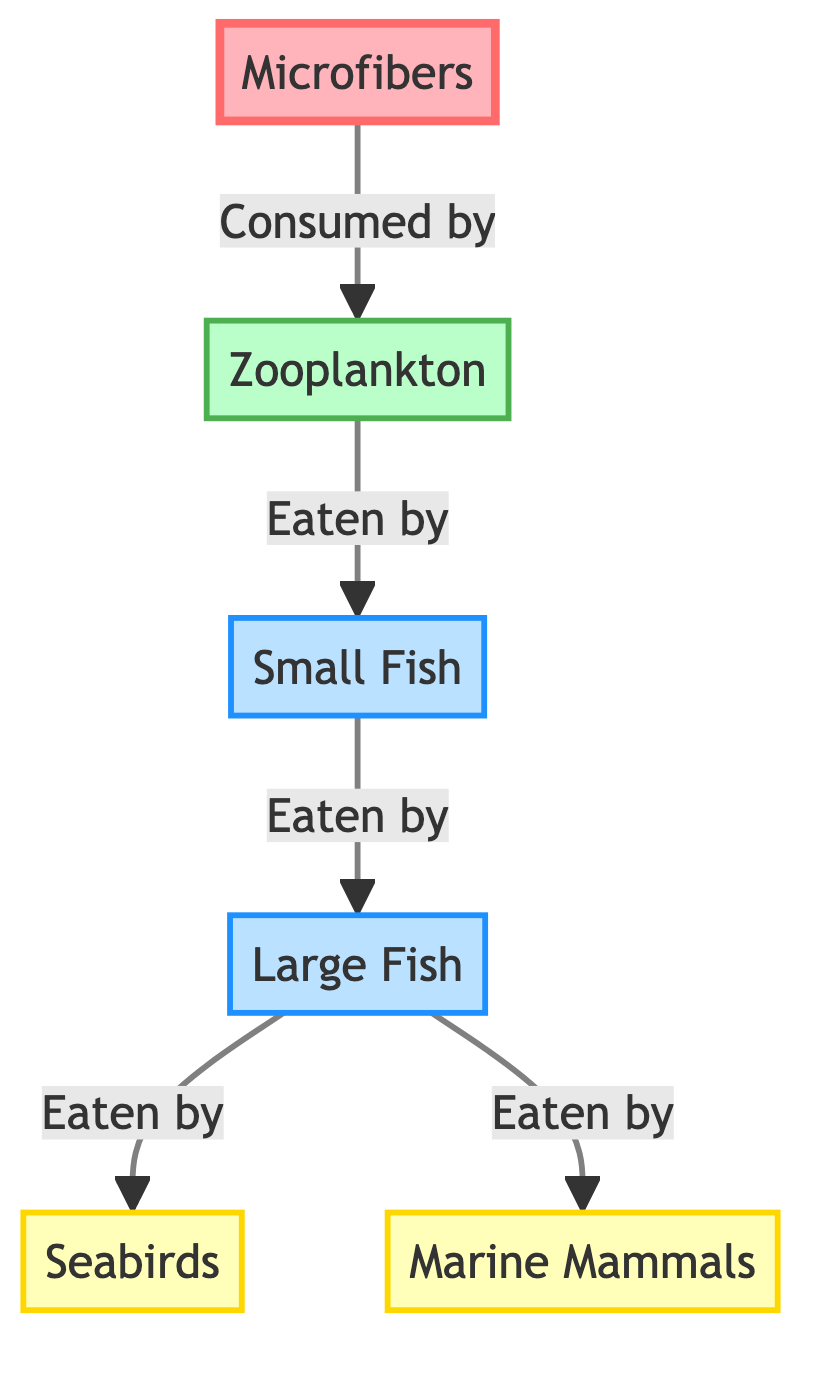What are the four organisms in this food chain? The diagram contains four organisms: Microfibers, Zooplankton, Small Fish, and Large Fish.
Answer: Microfibers, Zooplankton, Small Fish, Large Fish Which organism is directly consumed by Small Fish? According to the diagram, Small Fish eat Zooplankton.
Answer: Zooplankton How many types of predators are shown in this diagram? The diagram displays two types of predators: Seabirds and Marine Mammals.
Answer: Two What do large fish eat? The diagram shows that Large Fish are eaten by both Seabirds and Marine Mammals.
Answer: Seabirds, Marine Mammals What is the sequence of consumption starting from microfibers to the predators? The flow begins with Microfibers being consumed by Zooplankton, which are then eaten by Small Fish, followed by Large Fish, and finally by Seabirds and Marine Mammals.
Answer: Microfibers → Zooplankton → Small Fish → Large Fish → Seabirds/Marine Mammals How many links are there from microfibers to the top predators? To find the number of links, we count the connections: Microfibers to Zooplankton (1), Zooplankton to Small Fish (2), Small Fish to Large Fish (3), and Large Fish to two predators, Seabirds and Marine Mammals (4). Altogether, there are four links leading to predators.
Answer: Four Which group is at the end of the food chain? The diagram indicates that Seabirds and Marine Mammals are the final groups in the food chain, consuming the Large Fish.
Answer: Seabirds, Marine Mammals What is the role of zooplankton in this food chain? In the diagram, Zooplankton serve as the primary consumers that feed on Microfibers, thus linking the base of the food chain to Small Fish.
Answer: Primary consumers Which organism is impacted by microfiber pollution first? Microfiber pollution first impacts Zooplankton as they are the ones that consume microfibers directly.
Answer: Zooplankton 